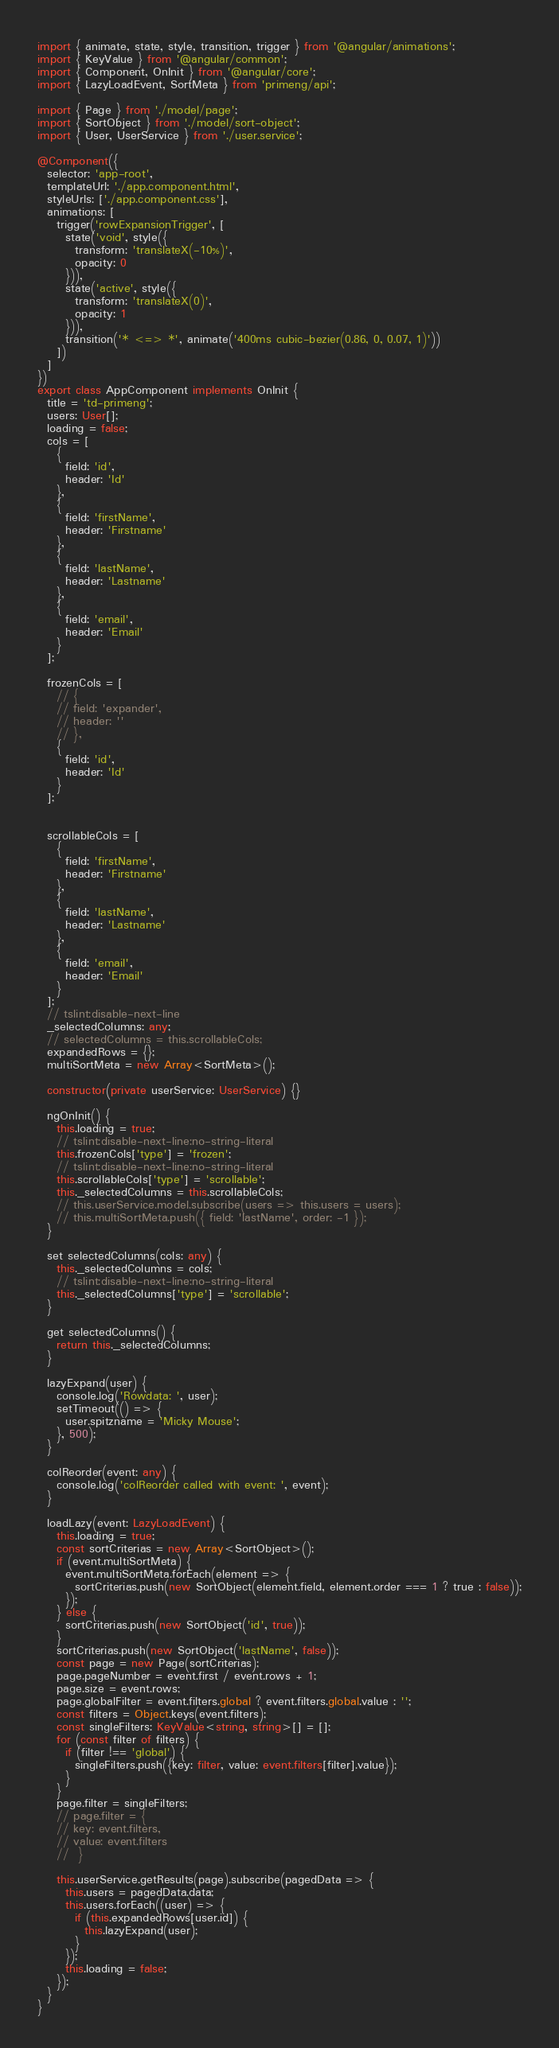<code> <loc_0><loc_0><loc_500><loc_500><_TypeScript_>import { animate, state, style, transition, trigger } from '@angular/animations';
import { KeyValue } from '@angular/common';
import { Component, OnInit } from '@angular/core';
import { LazyLoadEvent, SortMeta } from 'primeng/api';

import { Page } from './model/page';
import { SortObject } from './model/sort-object';
import { User, UserService } from './user.service';

@Component({
  selector: 'app-root',
  templateUrl: './app.component.html',
  styleUrls: ['./app.component.css'],
  animations: [
    trigger('rowExpansionTrigger', [
      state('void', style({
        transform: 'translateX(-10%)',
        opacity: 0
      })),
      state('active', style({
        transform: 'translateX(0)',
        opacity: 1
      })),
      transition('* <=> *', animate('400ms cubic-bezier(0.86, 0, 0.07, 1)'))
    ])
  ]
})
export class AppComponent implements OnInit {
  title = 'td-primeng';
  users: User[];
  loading = false;
  cols = [
    {
      field: 'id',
      header: 'Id'
    },
    {
      field: 'firstName',
      header: 'Firstname'
    },
    {
      field: 'lastName',
      header: 'Lastname'
    },
    {
      field: 'email',
      header: 'Email'
    }
  ];

  frozenCols = [
    // {
    // field: 'expander',
    // header: ''
    // },
    {
      field: 'id',
      header: 'Id'
    }
  ];


  scrollableCols = [
    {
      field: 'firstName',
      header: 'Firstname'
    },
    {
      field: 'lastName',
      header: 'Lastname'
    },
    {
      field: 'email',
      header: 'Email'
    }
  ];
  // tslint:disable-next-line
  _selectedColumns: any;
  // selectedColumns = this.scrollableCols;
  expandedRows = {};
  multiSortMeta = new Array<SortMeta>();

  constructor(private userService: UserService) {}

  ngOnInit() {
    this.loading = true;
    // tslint:disable-next-line:no-string-literal
    this.frozenCols['type'] = 'frozen';
    // tslint:disable-next-line:no-string-literal
    this.scrollableCols['type'] = 'scrollable';
    this._selectedColumns = this.scrollableCols;
    // this.userService.model.subscribe(users => this.users = users);
    // this.multiSortMeta.push({ field: 'lastName', order: -1 });
  }

  set selectedColumns(cols: any) {
    this._selectedColumns = cols;
    // tslint:disable-next-line:no-string-literal
    this._selectedColumns['type'] = 'scrollable';
  }

  get selectedColumns() {
    return this._selectedColumns;
  }

  lazyExpand(user) {
    console.log('Rowdata: ', user);
    setTimeout(() => {
      user.spitzname = 'Micky Mouse';
    }, 500);
  }

  colReorder(event: any) {
    console.log('colReorder called with event: ', event);
  }

  loadLazy(event: LazyLoadEvent) {
    this.loading = true;
    const sortCriterias = new Array<SortObject>();
    if (event.multiSortMeta) {
      event.multiSortMeta.forEach(element => {
        sortCriterias.push(new SortObject(element.field, element.order === 1 ? true : false));
      });
    } else {
      sortCriterias.push(new SortObject('id', true));
    }
    sortCriterias.push(new SortObject('lastName', false));
    const page = new Page(sortCriterias);
    page.pageNumber = event.first / event.rows + 1;
    page.size = event.rows;
    page.globalFilter = event.filters.global ? event.filters.global.value : '';
    const filters = Object.keys(event.filters);
    const singleFilters: KeyValue<string, string>[] = [];
    for (const filter of filters) {
      if (filter !== 'global') {
        singleFilters.push({key: filter, value: event.filters[filter].value});
      }
    }
    page.filter = singleFilters;
    // page.filter = {
    // key: event.filters,
    // value: event.filters
    //  }

    this.userService.getResults(page).subscribe(pagedData => {
      this.users = pagedData.data;
      this.users.forEach((user) => {
        if (this.expandedRows[user.id]) {
          this.lazyExpand(user);
        }
      });
      this.loading = false;
    });
  }
}
</code> 